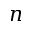Convert formula to latex. <formula><loc_0><loc_0><loc_500><loc_500>n</formula> 